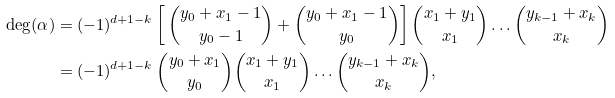<formula> <loc_0><loc_0><loc_500><loc_500>\deg ( \alpha ) & = ( - 1 ) ^ { d + 1 - k } \left [ \, \binom { y _ { 0 } + x _ { 1 } - 1 } { y _ { 0 } - 1 } + \binom { y _ { 0 } + x _ { 1 } - 1 } { y _ { 0 } } \right ] \binom { x _ { 1 } + y _ { 1 } } { x _ { 1 } } \dots \binom { y _ { k - 1 } + x _ { k } } { x _ { k } } \\ & = ( - 1 ) ^ { d + 1 - k } \, \binom { y _ { 0 } + x _ { 1 } } { y _ { 0 } } \binom { x _ { 1 } + y _ { 1 } } { x _ { 1 } } \dots \binom { y _ { k - 1 } + x _ { k } } { x _ { k } } ,</formula> 